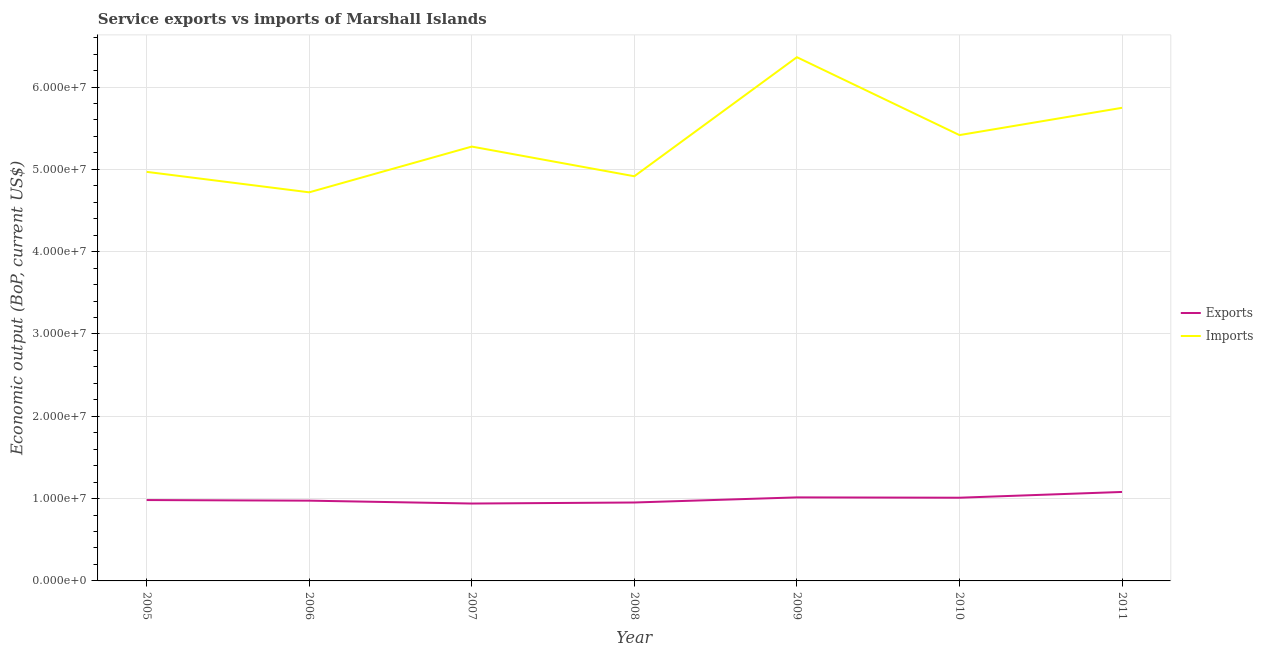Does the line corresponding to amount of service imports intersect with the line corresponding to amount of service exports?
Your answer should be very brief. No. Is the number of lines equal to the number of legend labels?
Your response must be concise. Yes. What is the amount of service exports in 2006?
Provide a succinct answer. 9.75e+06. Across all years, what is the maximum amount of service imports?
Your answer should be very brief. 6.36e+07. Across all years, what is the minimum amount of service exports?
Your answer should be compact. 9.40e+06. In which year was the amount of service exports minimum?
Offer a terse response. 2007. What is the total amount of service exports in the graph?
Provide a short and direct response. 6.96e+07. What is the difference between the amount of service imports in 2008 and that in 2009?
Your answer should be compact. -1.45e+07. What is the difference between the amount of service exports in 2005 and the amount of service imports in 2009?
Give a very brief answer. -5.38e+07. What is the average amount of service exports per year?
Provide a succinct answer. 9.94e+06. In the year 2011, what is the difference between the amount of service imports and amount of service exports?
Your answer should be compact. 4.67e+07. In how many years, is the amount of service imports greater than 56000000 US$?
Provide a succinct answer. 2. What is the ratio of the amount of service imports in 2006 to that in 2011?
Your answer should be compact. 0.82. Is the difference between the amount of service exports in 2007 and 2009 greater than the difference between the amount of service imports in 2007 and 2009?
Provide a short and direct response. Yes. What is the difference between the highest and the second highest amount of service imports?
Ensure brevity in your answer.  6.15e+06. What is the difference between the highest and the lowest amount of service imports?
Your answer should be compact. 1.64e+07. Is the sum of the amount of service exports in 2005 and 2008 greater than the maximum amount of service imports across all years?
Give a very brief answer. No. Is the amount of service exports strictly greater than the amount of service imports over the years?
Make the answer very short. No. How many lines are there?
Offer a terse response. 2. How many years are there in the graph?
Your answer should be compact. 7. Are the values on the major ticks of Y-axis written in scientific E-notation?
Ensure brevity in your answer.  Yes. Does the graph contain any zero values?
Offer a terse response. No. How many legend labels are there?
Your response must be concise. 2. What is the title of the graph?
Provide a short and direct response. Service exports vs imports of Marshall Islands. What is the label or title of the X-axis?
Your answer should be compact. Year. What is the label or title of the Y-axis?
Give a very brief answer. Economic output (BoP, current US$). What is the Economic output (BoP, current US$) of Exports in 2005?
Provide a short and direct response. 9.82e+06. What is the Economic output (BoP, current US$) of Imports in 2005?
Provide a short and direct response. 4.97e+07. What is the Economic output (BoP, current US$) of Exports in 2006?
Provide a short and direct response. 9.75e+06. What is the Economic output (BoP, current US$) of Imports in 2006?
Your answer should be very brief. 4.72e+07. What is the Economic output (BoP, current US$) of Exports in 2007?
Ensure brevity in your answer.  9.40e+06. What is the Economic output (BoP, current US$) of Imports in 2007?
Your answer should be very brief. 5.28e+07. What is the Economic output (BoP, current US$) in Exports in 2008?
Make the answer very short. 9.53e+06. What is the Economic output (BoP, current US$) in Imports in 2008?
Offer a terse response. 4.92e+07. What is the Economic output (BoP, current US$) in Exports in 2009?
Your answer should be very brief. 1.01e+07. What is the Economic output (BoP, current US$) of Imports in 2009?
Offer a terse response. 6.36e+07. What is the Economic output (BoP, current US$) in Exports in 2010?
Give a very brief answer. 1.01e+07. What is the Economic output (BoP, current US$) of Imports in 2010?
Make the answer very short. 5.42e+07. What is the Economic output (BoP, current US$) of Exports in 2011?
Offer a very short reply. 1.08e+07. What is the Economic output (BoP, current US$) of Imports in 2011?
Your answer should be very brief. 5.75e+07. Across all years, what is the maximum Economic output (BoP, current US$) of Exports?
Offer a terse response. 1.08e+07. Across all years, what is the maximum Economic output (BoP, current US$) in Imports?
Keep it short and to the point. 6.36e+07. Across all years, what is the minimum Economic output (BoP, current US$) of Exports?
Your response must be concise. 9.40e+06. Across all years, what is the minimum Economic output (BoP, current US$) in Imports?
Keep it short and to the point. 4.72e+07. What is the total Economic output (BoP, current US$) in Exports in the graph?
Your answer should be compact. 6.96e+07. What is the total Economic output (BoP, current US$) in Imports in the graph?
Give a very brief answer. 3.74e+08. What is the difference between the Economic output (BoP, current US$) of Exports in 2005 and that in 2006?
Provide a short and direct response. 7.30e+04. What is the difference between the Economic output (BoP, current US$) of Imports in 2005 and that in 2006?
Your answer should be very brief. 2.49e+06. What is the difference between the Economic output (BoP, current US$) in Exports in 2005 and that in 2007?
Your answer should be very brief. 4.23e+05. What is the difference between the Economic output (BoP, current US$) of Imports in 2005 and that in 2007?
Provide a short and direct response. -3.07e+06. What is the difference between the Economic output (BoP, current US$) of Exports in 2005 and that in 2008?
Your answer should be very brief. 2.97e+05. What is the difference between the Economic output (BoP, current US$) in Imports in 2005 and that in 2008?
Your response must be concise. 5.35e+05. What is the difference between the Economic output (BoP, current US$) of Exports in 2005 and that in 2009?
Provide a succinct answer. -3.23e+05. What is the difference between the Economic output (BoP, current US$) in Imports in 2005 and that in 2009?
Provide a short and direct response. -1.39e+07. What is the difference between the Economic output (BoP, current US$) of Exports in 2005 and that in 2010?
Make the answer very short. -2.83e+05. What is the difference between the Economic output (BoP, current US$) of Imports in 2005 and that in 2010?
Your answer should be very brief. -4.47e+06. What is the difference between the Economic output (BoP, current US$) in Exports in 2005 and that in 2011?
Keep it short and to the point. -9.84e+05. What is the difference between the Economic output (BoP, current US$) in Imports in 2005 and that in 2011?
Give a very brief answer. -7.78e+06. What is the difference between the Economic output (BoP, current US$) of Exports in 2006 and that in 2007?
Keep it short and to the point. 3.50e+05. What is the difference between the Economic output (BoP, current US$) of Imports in 2006 and that in 2007?
Give a very brief answer. -5.56e+06. What is the difference between the Economic output (BoP, current US$) of Exports in 2006 and that in 2008?
Provide a succinct answer. 2.24e+05. What is the difference between the Economic output (BoP, current US$) of Imports in 2006 and that in 2008?
Offer a terse response. -1.95e+06. What is the difference between the Economic output (BoP, current US$) of Exports in 2006 and that in 2009?
Offer a very short reply. -3.96e+05. What is the difference between the Economic output (BoP, current US$) of Imports in 2006 and that in 2009?
Provide a succinct answer. -1.64e+07. What is the difference between the Economic output (BoP, current US$) of Exports in 2006 and that in 2010?
Offer a terse response. -3.56e+05. What is the difference between the Economic output (BoP, current US$) of Imports in 2006 and that in 2010?
Offer a terse response. -6.95e+06. What is the difference between the Economic output (BoP, current US$) of Exports in 2006 and that in 2011?
Offer a very short reply. -1.06e+06. What is the difference between the Economic output (BoP, current US$) in Imports in 2006 and that in 2011?
Offer a terse response. -1.03e+07. What is the difference between the Economic output (BoP, current US$) of Exports in 2007 and that in 2008?
Give a very brief answer. -1.26e+05. What is the difference between the Economic output (BoP, current US$) in Imports in 2007 and that in 2008?
Provide a short and direct response. 3.61e+06. What is the difference between the Economic output (BoP, current US$) of Exports in 2007 and that in 2009?
Your answer should be compact. -7.45e+05. What is the difference between the Economic output (BoP, current US$) of Imports in 2007 and that in 2009?
Give a very brief answer. -1.09e+07. What is the difference between the Economic output (BoP, current US$) in Exports in 2007 and that in 2010?
Give a very brief answer. -7.06e+05. What is the difference between the Economic output (BoP, current US$) of Imports in 2007 and that in 2010?
Keep it short and to the point. -1.40e+06. What is the difference between the Economic output (BoP, current US$) of Exports in 2007 and that in 2011?
Keep it short and to the point. -1.41e+06. What is the difference between the Economic output (BoP, current US$) of Imports in 2007 and that in 2011?
Keep it short and to the point. -4.71e+06. What is the difference between the Economic output (BoP, current US$) in Exports in 2008 and that in 2009?
Keep it short and to the point. -6.20e+05. What is the difference between the Economic output (BoP, current US$) in Imports in 2008 and that in 2009?
Keep it short and to the point. -1.45e+07. What is the difference between the Economic output (BoP, current US$) in Exports in 2008 and that in 2010?
Your response must be concise. -5.80e+05. What is the difference between the Economic output (BoP, current US$) in Imports in 2008 and that in 2010?
Provide a short and direct response. -5.00e+06. What is the difference between the Economic output (BoP, current US$) in Exports in 2008 and that in 2011?
Your response must be concise. -1.28e+06. What is the difference between the Economic output (BoP, current US$) in Imports in 2008 and that in 2011?
Ensure brevity in your answer.  -8.32e+06. What is the difference between the Economic output (BoP, current US$) of Exports in 2009 and that in 2010?
Give a very brief answer. 3.96e+04. What is the difference between the Economic output (BoP, current US$) in Imports in 2009 and that in 2010?
Give a very brief answer. 9.46e+06. What is the difference between the Economic output (BoP, current US$) in Exports in 2009 and that in 2011?
Your answer should be very brief. -6.61e+05. What is the difference between the Economic output (BoP, current US$) of Imports in 2009 and that in 2011?
Your answer should be very brief. 6.15e+06. What is the difference between the Economic output (BoP, current US$) in Exports in 2010 and that in 2011?
Give a very brief answer. -7.01e+05. What is the difference between the Economic output (BoP, current US$) in Imports in 2010 and that in 2011?
Give a very brief answer. -3.31e+06. What is the difference between the Economic output (BoP, current US$) in Exports in 2005 and the Economic output (BoP, current US$) in Imports in 2006?
Your answer should be compact. -3.74e+07. What is the difference between the Economic output (BoP, current US$) of Exports in 2005 and the Economic output (BoP, current US$) of Imports in 2007?
Offer a very short reply. -4.29e+07. What is the difference between the Economic output (BoP, current US$) in Exports in 2005 and the Economic output (BoP, current US$) in Imports in 2008?
Your answer should be very brief. -3.93e+07. What is the difference between the Economic output (BoP, current US$) in Exports in 2005 and the Economic output (BoP, current US$) in Imports in 2009?
Keep it short and to the point. -5.38e+07. What is the difference between the Economic output (BoP, current US$) in Exports in 2005 and the Economic output (BoP, current US$) in Imports in 2010?
Give a very brief answer. -4.43e+07. What is the difference between the Economic output (BoP, current US$) of Exports in 2005 and the Economic output (BoP, current US$) of Imports in 2011?
Offer a very short reply. -4.77e+07. What is the difference between the Economic output (BoP, current US$) of Exports in 2006 and the Economic output (BoP, current US$) of Imports in 2007?
Your answer should be very brief. -4.30e+07. What is the difference between the Economic output (BoP, current US$) in Exports in 2006 and the Economic output (BoP, current US$) in Imports in 2008?
Keep it short and to the point. -3.94e+07. What is the difference between the Economic output (BoP, current US$) of Exports in 2006 and the Economic output (BoP, current US$) of Imports in 2009?
Offer a terse response. -5.39e+07. What is the difference between the Economic output (BoP, current US$) in Exports in 2006 and the Economic output (BoP, current US$) in Imports in 2010?
Keep it short and to the point. -4.44e+07. What is the difference between the Economic output (BoP, current US$) in Exports in 2006 and the Economic output (BoP, current US$) in Imports in 2011?
Give a very brief answer. -4.77e+07. What is the difference between the Economic output (BoP, current US$) of Exports in 2007 and the Economic output (BoP, current US$) of Imports in 2008?
Offer a very short reply. -3.98e+07. What is the difference between the Economic output (BoP, current US$) in Exports in 2007 and the Economic output (BoP, current US$) in Imports in 2009?
Your answer should be very brief. -5.42e+07. What is the difference between the Economic output (BoP, current US$) in Exports in 2007 and the Economic output (BoP, current US$) in Imports in 2010?
Your response must be concise. -4.48e+07. What is the difference between the Economic output (BoP, current US$) in Exports in 2007 and the Economic output (BoP, current US$) in Imports in 2011?
Your response must be concise. -4.81e+07. What is the difference between the Economic output (BoP, current US$) in Exports in 2008 and the Economic output (BoP, current US$) in Imports in 2009?
Ensure brevity in your answer.  -5.41e+07. What is the difference between the Economic output (BoP, current US$) of Exports in 2008 and the Economic output (BoP, current US$) of Imports in 2010?
Provide a succinct answer. -4.46e+07. What is the difference between the Economic output (BoP, current US$) of Exports in 2008 and the Economic output (BoP, current US$) of Imports in 2011?
Your response must be concise. -4.79e+07. What is the difference between the Economic output (BoP, current US$) of Exports in 2009 and the Economic output (BoP, current US$) of Imports in 2010?
Your response must be concise. -4.40e+07. What is the difference between the Economic output (BoP, current US$) in Exports in 2009 and the Economic output (BoP, current US$) in Imports in 2011?
Offer a terse response. -4.73e+07. What is the difference between the Economic output (BoP, current US$) of Exports in 2010 and the Economic output (BoP, current US$) of Imports in 2011?
Provide a short and direct response. -4.74e+07. What is the average Economic output (BoP, current US$) of Exports per year?
Provide a short and direct response. 9.94e+06. What is the average Economic output (BoP, current US$) in Imports per year?
Provide a succinct answer. 5.34e+07. In the year 2005, what is the difference between the Economic output (BoP, current US$) in Exports and Economic output (BoP, current US$) in Imports?
Give a very brief answer. -3.99e+07. In the year 2006, what is the difference between the Economic output (BoP, current US$) of Exports and Economic output (BoP, current US$) of Imports?
Ensure brevity in your answer.  -3.75e+07. In the year 2007, what is the difference between the Economic output (BoP, current US$) in Exports and Economic output (BoP, current US$) in Imports?
Make the answer very short. -4.34e+07. In the year 2008, what is the difference between the Economic output (BoP, current US$) in Exports and Economic output (BoP, current US$) in Imports?
Offer a very short reply. -3.96e+07. In the year 2009, what is the difference between the Economic output (BoP, current US$) in Exports and Economic output (BoP, current US$) in Imports?
Give a very brief answer. -5.35e+07. In the year 2010, what is the difference between the Economic output (BoP, current US$) of Exports and Economic output (BoP, current US$) of Imports?
Keep it short and to the point. -4.41e+07. In the year 2011, what is the difference between the Economic output (BoP, current US$) of Exports and Economic output (BoP, current US$) of Imports?
Your response must be concise. -4.67e+07. What is the ratio of the Economic output (BoP, current US$) of Exports in 2005 to that in 2006?
Your answer should be compact. 1.01. What is the ratio of the Economic output (BoP, current US$) in Imports in 2005 to that in 2006?
Offer a terse response. 1.05. What is the ratio of the Economic output (BoP, current US$) in Exports in 2005 to that in 2007?
Make the answer very short. 1.04. What is the ratio of the Economic output (BoP, current US$) in Imports in 2005 to that in 2007?
Keep it short and to the point. 0.94. What is the ratio of the Economic output (BoP, current US$) of Exports in 2005 to that in 2008?
Ensure brevity in your answer.  1.03. What is the ratio of the Economic output (BoP, current US$) in Imports in 2005 to that in 2008?
Make the answer very short. 1.01. What is the ratio of the Economic output (BoP, current US$) of Exports in 2005 to that in 2009?
Your response must be concise. 0.97. What is the ratio of the Economic output (BoP, current US$) in Imports in 2005 to that in 2009?
Ensure brevity in your answer.  0.78. What is the ratio of the Economic output (BoP, current US$) of Imports in 2005 to that in 2010?
Ensure brevity in your answer.  0.92. What is the ratio of the Economic output (BoP, current US$) in Exports in 2005 to that in 2011?
Provide a short and direct response. 0.91. What is the ratio of the Economic output (BoP, current US$) in Imports in 2005 to that in 2011?
Your answer should be very brief. 0.86. What is the ratio of the Economic output (BoP, current US$) of Exports in 2006 to that in 2007?
Your answer should be very brief. 1.04. What is the ratio of the Economic output (BoP, current US$) in Imports in 2006 to that in 2007?
Provide a short and direct response. 0.89. What is the ratio of the Economic output (BoP, current US$) in Exports in 2006 to that in 2008?
Make the answer very short. 1.02. What is the ratio of the Economic output (BoP, current US$) in Imports in 2006 to that in 2008?
Your answer should be compact. 0.96. What is the ratio of the Economic output (BoP, current US$) of Imports in 2006 to that in 2009?
Provide a succinct answer. 0.74. What is the ratio of the Economic output (BoP, current US$) in Exports in 2006 to that in 2010?
Offer a very short reply. 0.96. What is the ratio of the Economic output (BoP, current US$) of Imports in 2006 to that in 2010?
Offer a terse response. 0.87. What is the ratio of the Economic output (BoP, current US$) in Exports in 2006 to that in 2011?
Your answer should be very brief. 0.9. What is the ratio of the Economic output (BoP, current US$) in Imports in 2006 to that in 2011?
Your answer should be very brief. 0.82. What is the ratio of the Economic output (BoP, current US$) in Exports in 2007 to that in 2008?
Provide a short and direct response. 0.99. What is the ratio of the Economic output (BoP, current US$) in Imports in 2007 to that in 2008?
Offer a very short reply. 1.07. What is the ratio of the Economic output (BoP, current US$) of Exports in 2007 to that in 2009?
Offer a terse response. 0.93. What is the ratio of the Economic output (BoP, current US$) in Imports in 2007 to that in 2009?
Your response must be concise. 0.83. What is the ratio of the Economic output (BoP, current US$) in Exports in 2007 to that in 2010?
Offer a terse response. 0.93. What is the ratio of the Economic output (BoP, current US$) in Imports in 2007 to that in 2010?
Your answer should be compact. 0.97. What is the ratio of the Economic output (BoP, current US$) in Exports in 2007 to that in 2011?
Provide a succinct answer. 0.87. What is the ratio of the Economic output (BoP, current US$) of Imports in 2007 to that in 2011?
Your answer should be compact. 0.92. What is the ratio of the Economic output (BoP, current US$) of Exports in 2008 to that in 2009?
Provide a short and direct response. 0.94. What is the ratio of the Economic output (BoP, current US$) in Imports in 2008 to that in 2009?
Provide a succinct answer. 0.77. What is the ratio of the Economic output (BoP, current US$) of Exports in 2008 to that in 2010?
Provide a succinct answer. 0.94. What is the ratio of the Economic output (BoP, current US$) in Imports in 2008 to that in 2010?
Keep it short and to the point. 0.91. What is the ratio of the Economic output (BoP, current US$) of Exports in 2008 to that in 2011?
Your answer should be compact. 0.88. What is the ratio of the Economic output (BoP, current US$) in Imports in 2008 to that in 2011?
Provide a short and direct response. 0.86. What is the ratio of the Economic output (BoP, current US$) of Imports in 2009 to that in 2010?
Ensure brevity in your answer.  1.17. What is the ratio of the Economic output (BoP, current US$) of Exports in 2009 to that in 2011?
Keep it short and to the point. 0.94. What is the ratio of the Economic output (BoP, current US$) of Imports in 2009 to that in 2011?
Offer a terse response. 1.11. What is the ratio of the Economic output (BoP, current US$) of Exports in 2010 to that in 2011?
Offer a terse response. 0.94. What is the ratio of the Economic output (BoP, current US$) of Imports in 2010 to that in 2011?
Offer a terse response. 0.94. What is the difference between the highest and the second highest Economic output (BoP, current US$) in Exports?
Give a very brief answer. 6.61e+05. What is the difference between the highest and the second highest Economic output (BoP, current US$) of Imports?
Make the answer very short. 6.15e+06. What is the difference between the highest and the lowest Economic output (BoP, current US$) in Exports?
Offer a very short reply. 1.41e+06. What is the difference between the highest and the lowest Economic output (BoP, current US$) in Imports?
Offer a very short reply. 1.64e+07. 